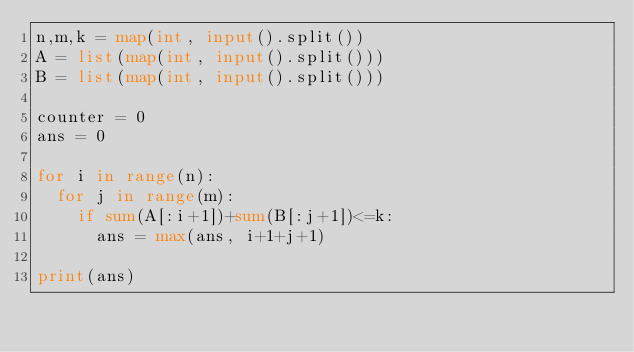<code> <loc_0><loc_0><loc_500><loc_500><_Python_>n,m,k = map(int, input().split())
A = list(map(int, input().split()))
B = list(map(int, input().split()))

counter = 0
ans = 0

for i in range(n):
  for j in range(m):
    if sum(A[:i+1])+sum(B[:j+1])<=k:
      ans = max(ans, i+1+j+1)
      
print(ans)</code> 